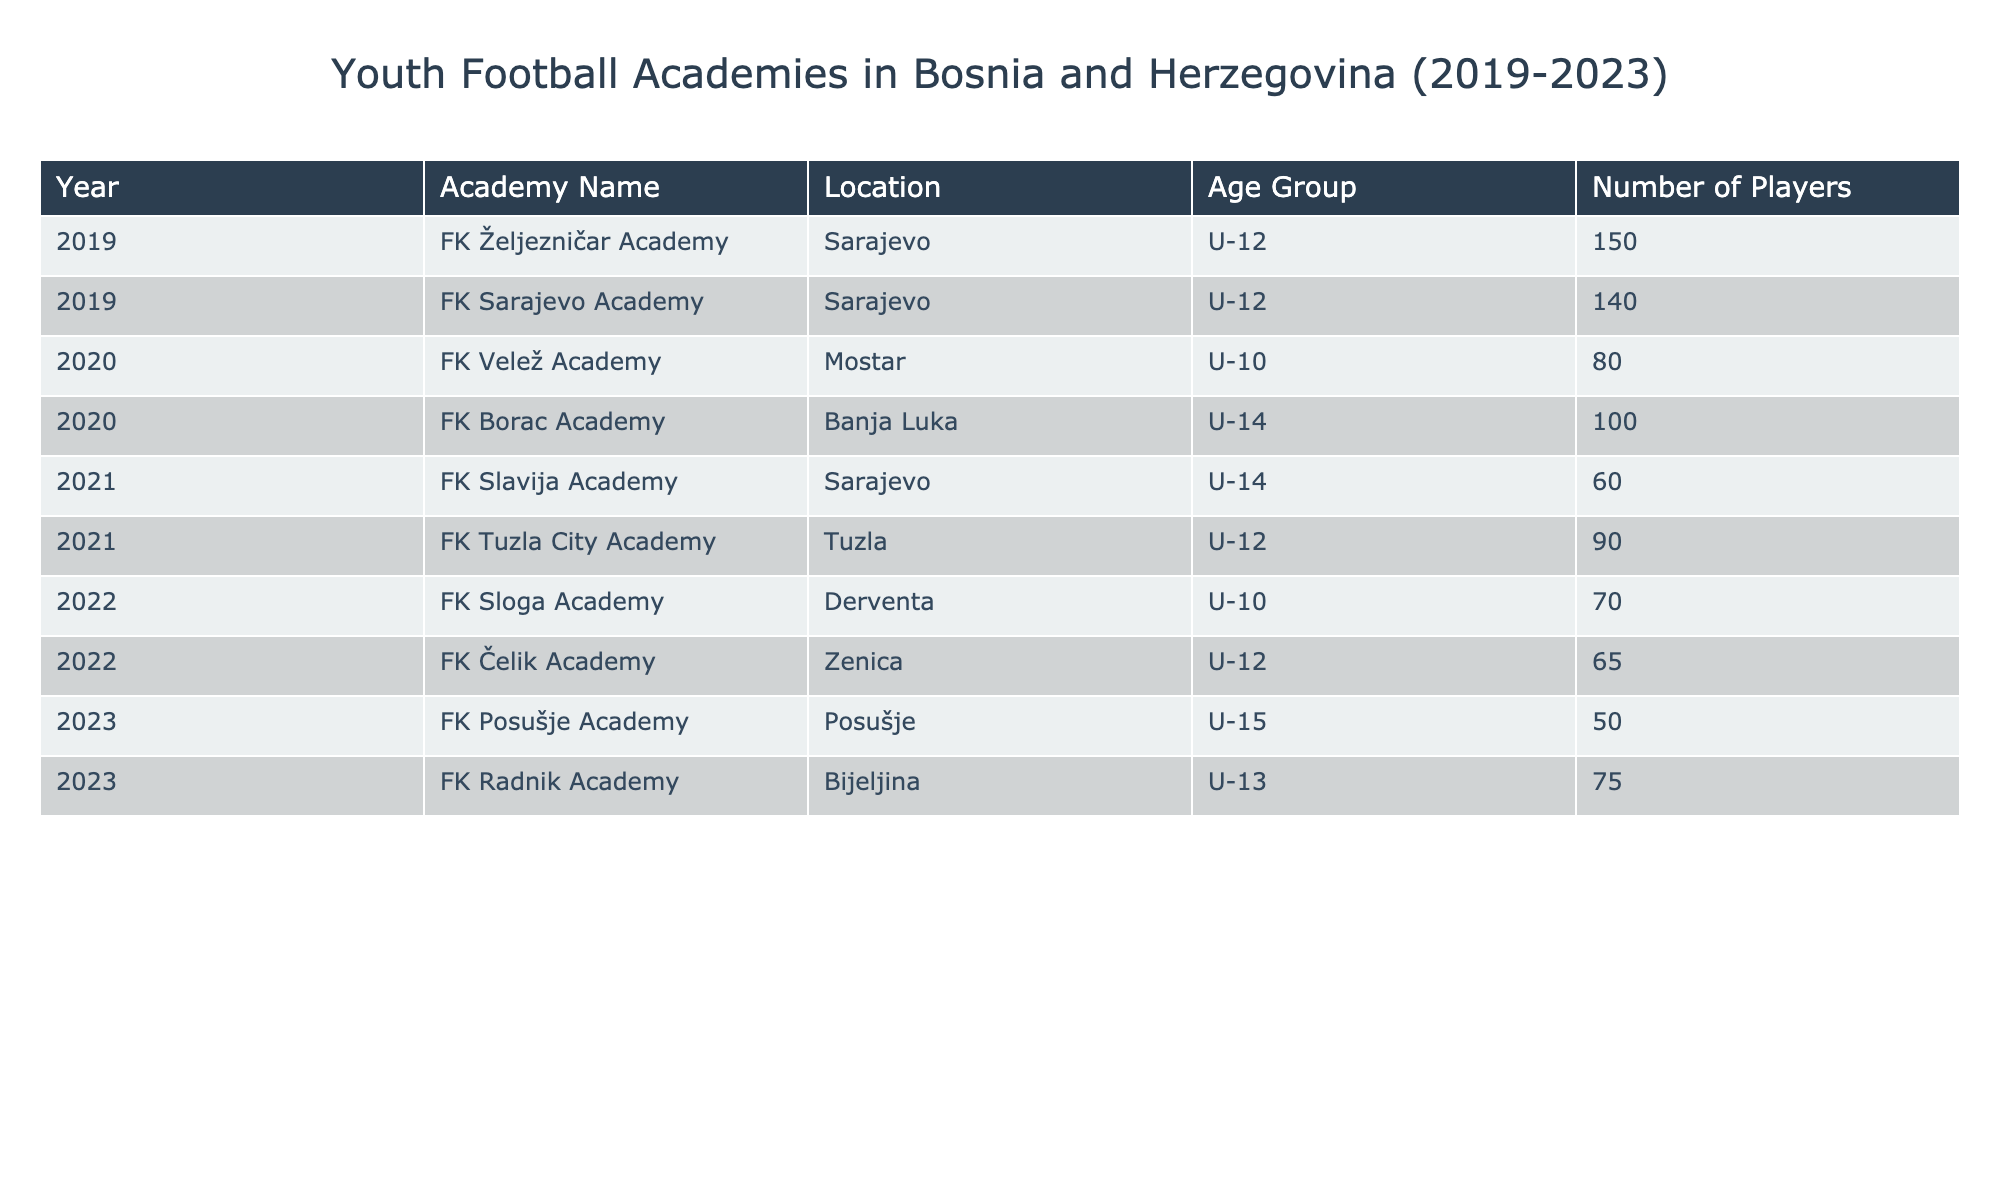What is the total number of players in all academies established in 2020? In 2020, there are two academies: FK Velež Academy with 80 players and FK Borac Academy with 100 players. Adding these gives 80 + 100 = 180.
Answer: 180 Which academy had the highest number of players in 2019? In 2019, the FK Željezničar Academy had 150 players, while FK Sarajevo Academy had 140 players. Therefore, FK Željezničar Academy had the highest number.
Answer: FK Željezničar Academy How many academies were established in Tuzla? The table shows that there is one academy established in Tuzla, which is FK Tuzla City Academy.
Answer: 1 What is the average number of players per academy for the year 2021? In 2021, there are two academies: FK Slavija Academy with 60 players and FK Tuzla City Academy with 90 players. The total number of players is 60 + 90 = 150. Average is 150 / 2 = 75.
Answer: 75 Did any academy established in 2022 have players in the U-15 age group? The FK Sloga Academy (U-10) and FK Čelik Academy (U-12) are the only academies from 2022. Both do not have players in the U-15 group, hence the answer is no.
Answer: No Which age group had the least number of players across all years in the table? Looking at age groups across all years, the least number of players is associated with U-15 (50 players in 2023 via FK Posušje Academy). This shows U-15 had the least.
Answer: U-15 What is the difference in the number of players between the academies in 2019 and 2023? In 2019, the total players were 150 + 140 = 290. In 2023, the total is 50 + 75 = 125. The difference is 290 - 125 = 165.
Answer: 165 Which locations have established academies in both 2019 and 2021? The table shows Sarajevo (FK Željezničar and FK Sarajevo in 2019; FK Slavija in 2021) is the only location with academies in both years.
Answer: Sarajevo In which year did the most academies establish their first season? Examining the data, 3 academies were established in 2021 (FK Slavija, FK Tuzla City, and FK Radnik) compared to others. Thus, 2021 had the most academies.
Answer: 2021 